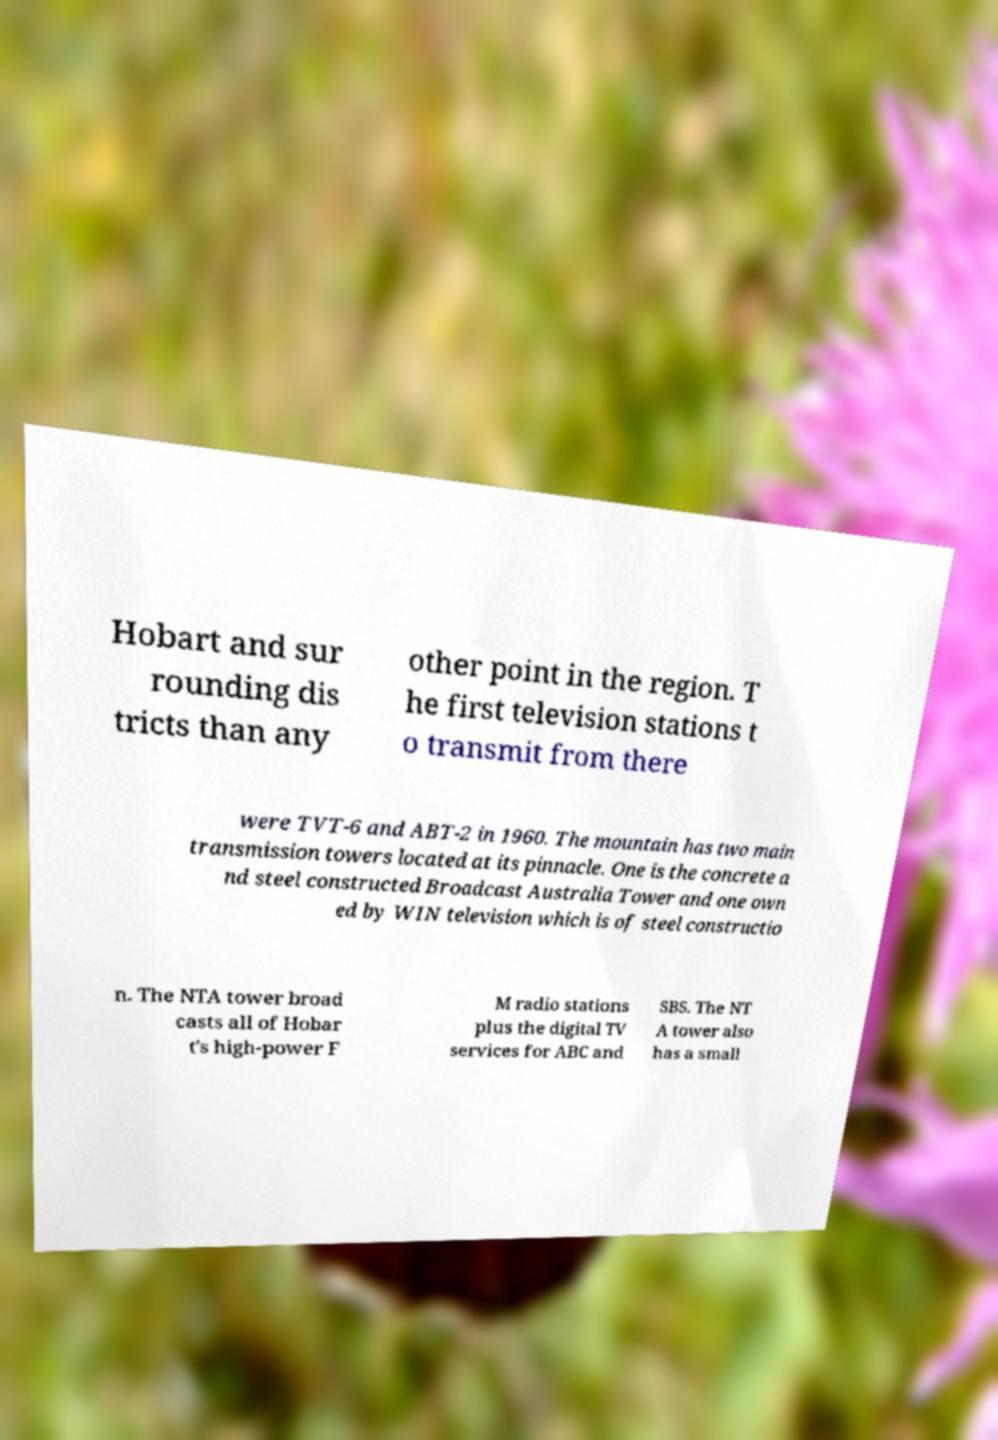Could you extract and type out the text from this image? Hobart and sur rounding dis tricts than any other point in the region. T he first television stations t o transmit from there were TVT-6 and ABT-2 in 1960. The mountain has two main transmission towers located at its pinnacle. One is the concrete a nd steel constructed Broadcast Australia Tower and one own ed by WIN television which is of steel constructio n. The NTA tower broad casts all of Hobar t's high-power F M radio stations plus the digital TV services for ABC and SBS. The NT A tower also has a small 